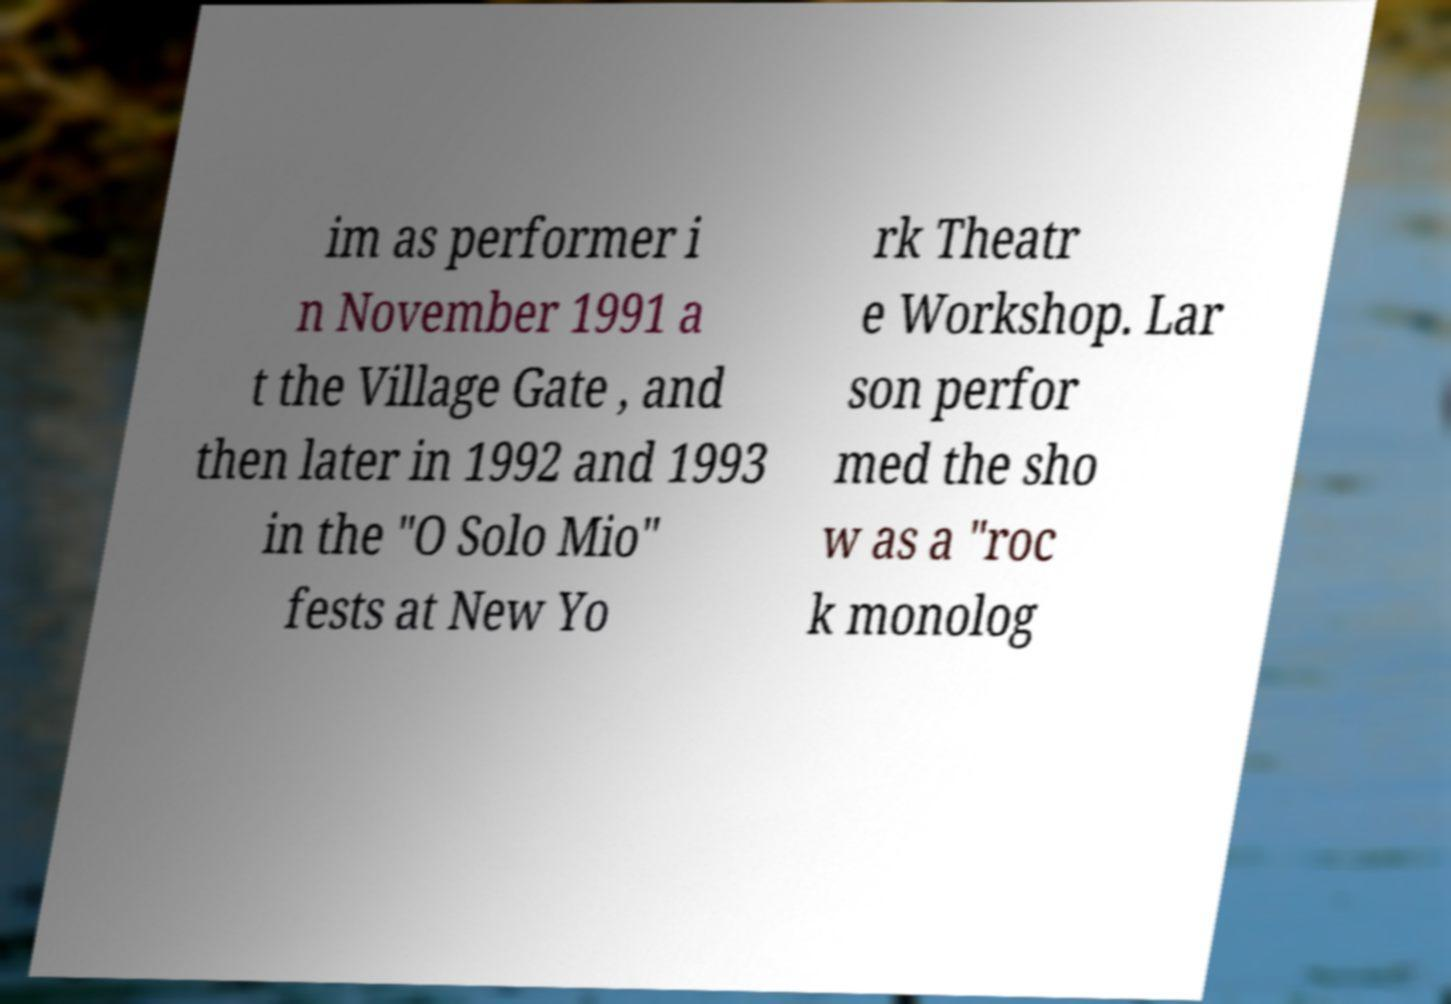Could you extract and type out the text from this image? im as performer i n November 1991 a t the Village Gate , and then later in 1992 and 1993 in the "O Solo Mio" fests at New Yo rk Theatr e Workshop. Lar son perfor med the sho w as a "roc k monolog 